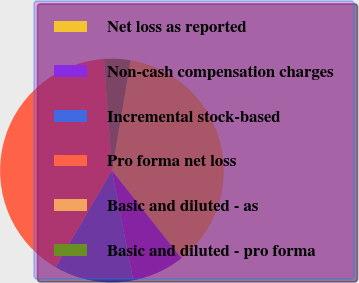<chart> <loc_0><loc_0><loc_500><loc_500><pie_chart><fcel>Net loss as reported<fcel>Non-cash compensation charges<fcel>Incremental stock-based<fcel>Pro forma net loss<fcel>Basic and diluted - as<fcel>Basic and diluted - pro forma<nl><fcel>36.66%<fcel>7.62%<fcel>11.44%<fcel>40.47%<fcel>0.0%<fcel>3.81%<nl></chart> 